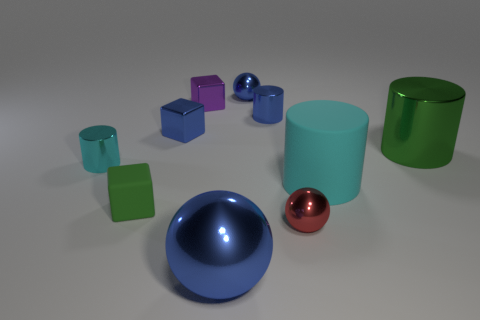What is the shape of the small object that is both in front of the cyan shiny cylinder and left of the tiny blue cylinder? cube 